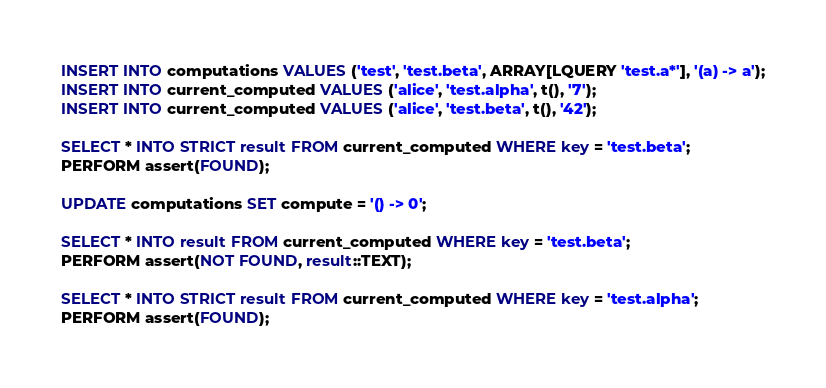Convert code to text. <code><loc_0><loc_0><loc_500><loc_500><_SQL_>INSERT INTO computations VALUES ('test', 'test.beta', ARRAY[LQUERY 'test.a*'], '(a) -> a');
INSERT INTO current_computed VALUES ('alice', 'test.alpha', t(), '7');
INSERT INTO current_computed VALUES ('alice', 'test.beta', t(), '42');

SELECT * INTO STRICT result FROM current_computed WHERE key = 'test.beta';
PERFORM assert(FOUND);

UPDATE computations SET compute = '() -> 0';

SELECT * INTO result FROM current_computed WHERE key = 'test.beta';
PERFORM assert(NOT FOUND, result::TEXT);

SELECT * INTO STRICT result FROM current_computed WHERE key = 'test.alpha';
PERFORM assert(FOUND);
</code> 